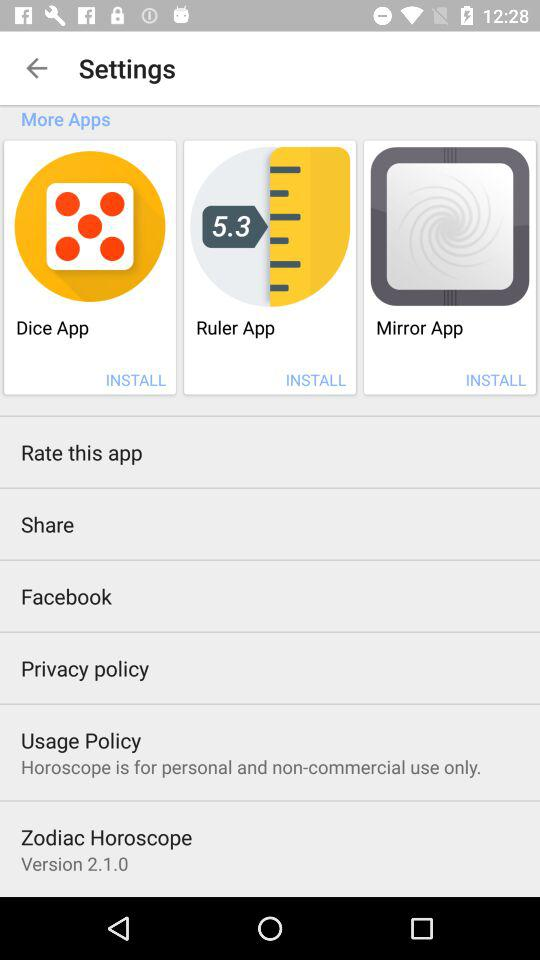How many apps are available to be installed?
Answer the question using a single word or phrase. 3 